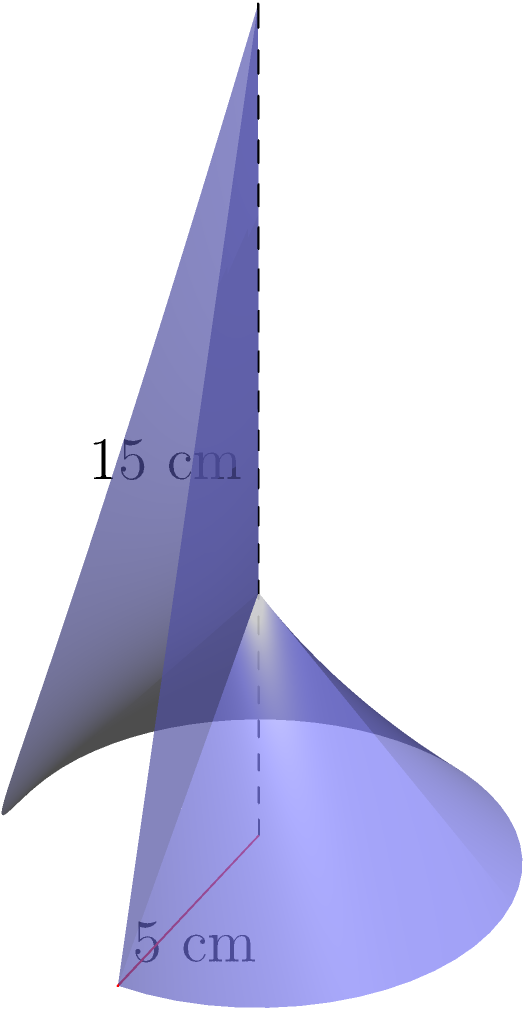During a protest, law enforcement officers confiscate a cone-shaped megaphone. The megaphone has a height of 15 cm and a base radius of 5 cm. Calculate the volume of this megaphone to determine its potential sound amplification capacity. Round your answer to the nearest cubic centimeter. To calculate the volume of a cone, we use the formula:

$$V = \frac{1}{3}\pi r^2 h$$

Where:
$V$ = volume
$r$ = radius of the base
$h$ = height of the cone

Given:
$r = 5$ cm
$h = 15$ cm

Let's substitute these values into the formula:

$$V = \frac{1}{3}\pi (5\text{ cm})^2 (15\text{ cm})$$

$$V = \frac{1}{3}\pi (25\text{ cm}^2) (15\text{ cm})$$

$$V = 5\pi (25\text{ cm}^3)$$

$$V = 125\pi\text{ cm}^3$$

$$V \approx 392.7\text{ cm}^3$$

Rounding to the nearest cubic centimeter:

$$V \approx 393\text{ cm}^3$$
Answer: 393 cm³ 